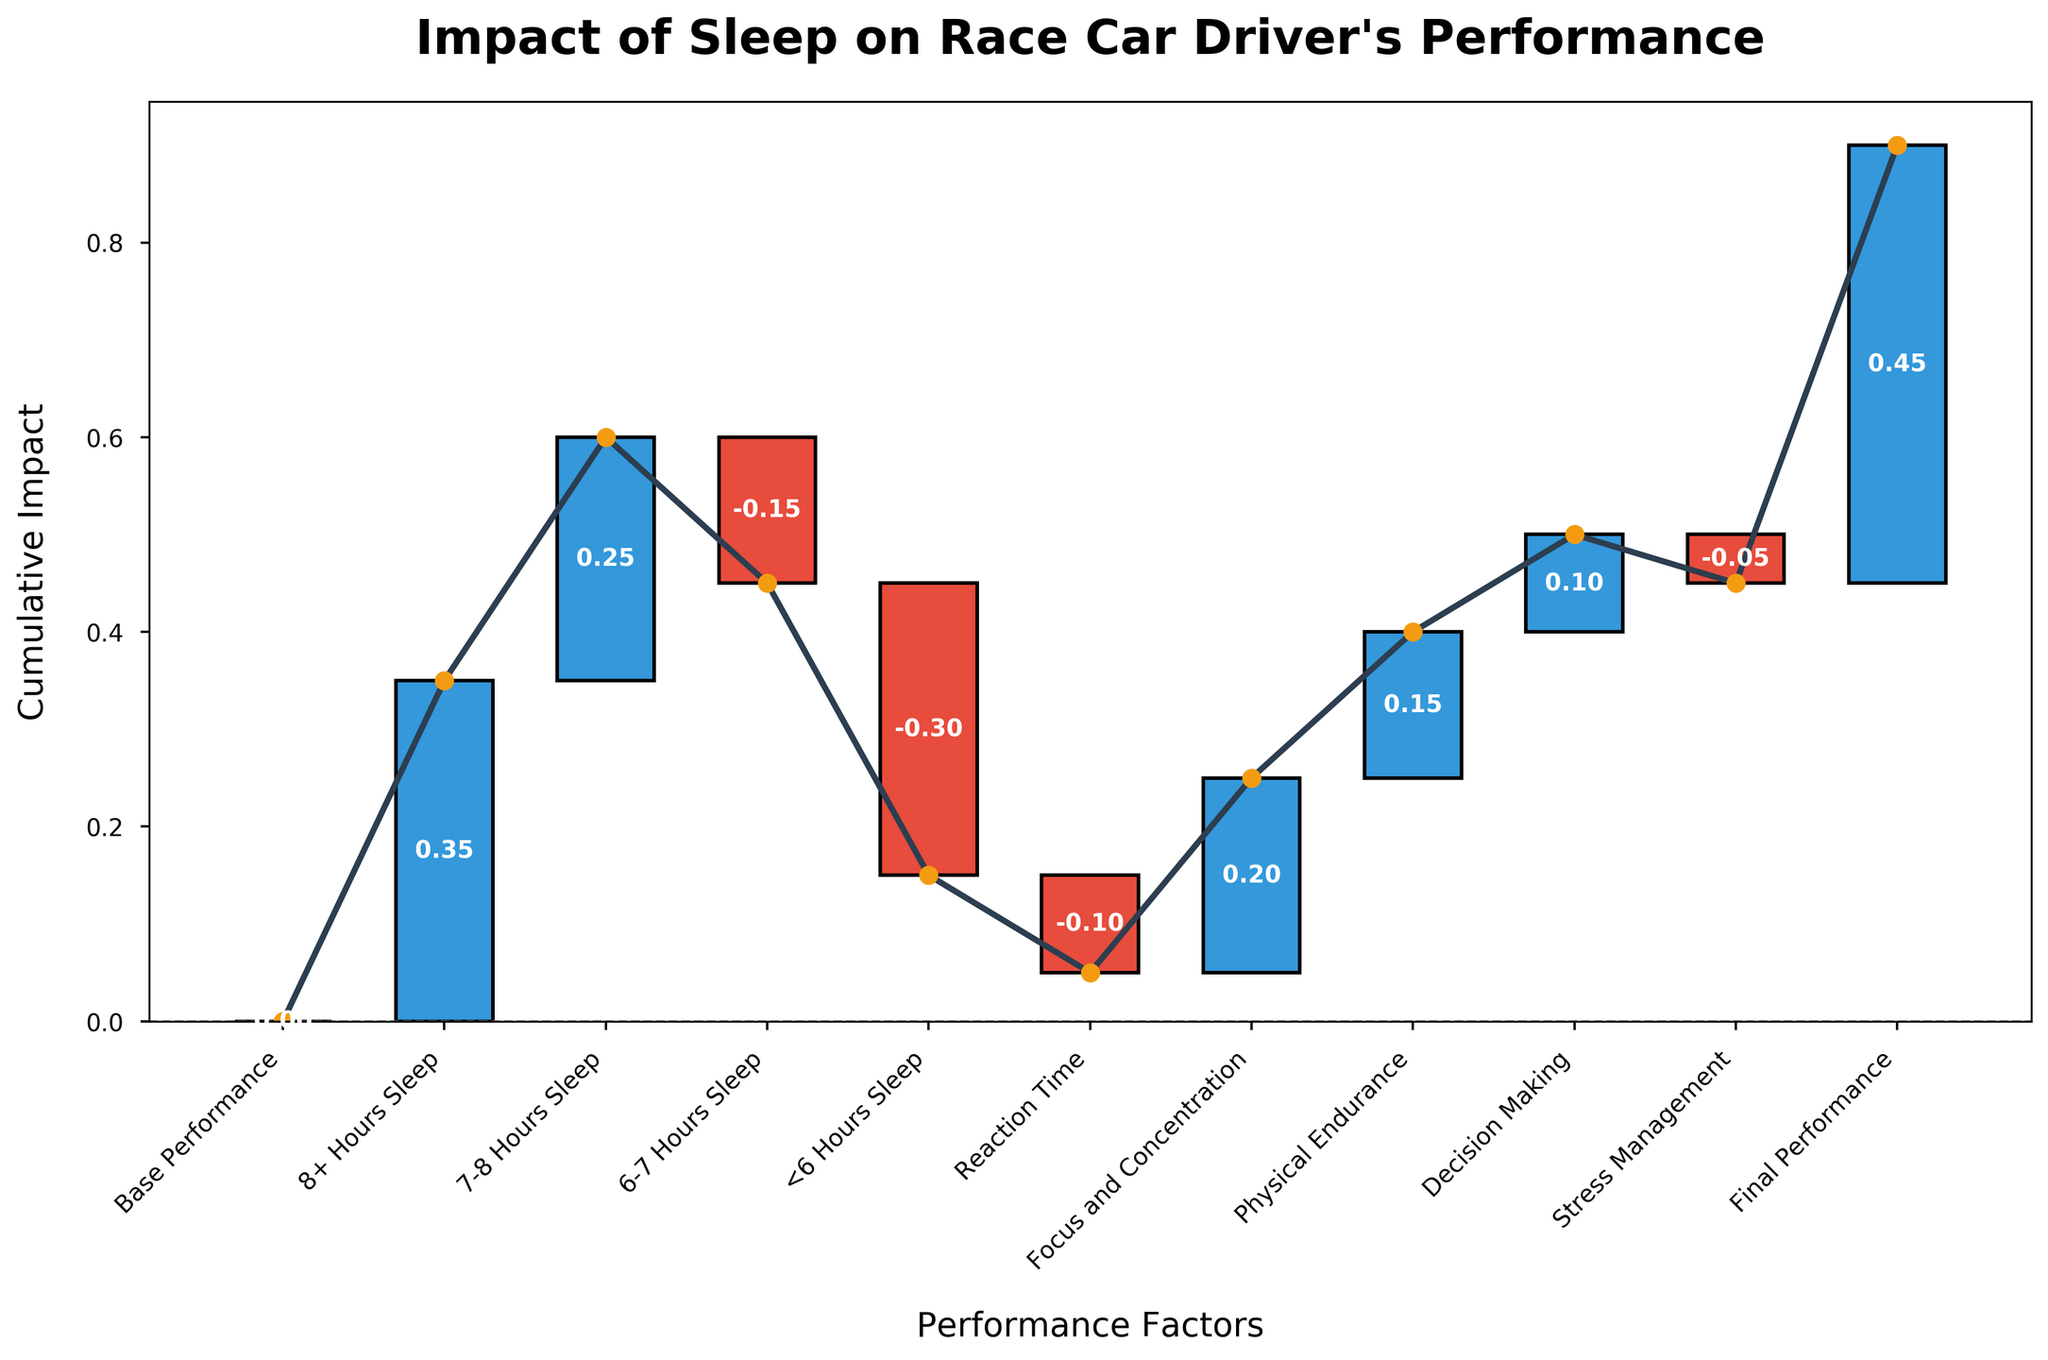What is the title of the plot? The title of the plot is clearly displayed at the top.
Answer: Impact of Sleep on Race Car Driver's Performance How does sleep duration of less than 6 hours affect the performance metric? The bar labeled "<6 Hours Sleep" shows a negative value, indicating it decreases the performance.
Answer: -0.30 What is the cumulative impact on performance after considering 7-8 hours of sleep? Summing the base performance (0) and the impact of 7-8 hours of sleep (+0.25) gives the cumulative impact.
Answer: +0.25 Which sleep duration category has a positive impact but less than 8+ hours of sleep? By comparing the labels and their values—both 7-8 Hours Sleep (+0.25) and 6-7 Hours Sleep (-0.15), only the 7-8 Hours Sleep has a positive impact, but less than 8+ Hours Sleep (+0.35).
Answer: 7-8 Hours Sleep Which factor contributes the most negatively to performance? Among the bars with negative values, "<6 Hours Sleep" has the lowest value (-0.30).
Answer: <6 Hours Sleep How much does the total impact of physical endurance, decision making, and stress management influence the final performance? Adding up the values for physical endurance (+0.15), decision making (+0.10), and stress management (-0.05) gives the total impact.
Answer: +0.20 What is the difference in impact between 8+ Hours Sleep and Reaction Time on performance? Subtract the value of reaction time (-0.10) from the value of 8+ Hours Sleep (+0.35).
Answer: +0.45 What is the final performance impact after accounting for all factors? The figure shows the final cumulative impact listed as Final Performance.
Answer: +0.45 Which factor appears to improve performance the most? By observing the height of the positive bars, 8+ Hours Sleep has the highest positive impact (+0.35).
Answer: 8+ Hours Sleep What category has a negative influence after Focus and Concentration? Looking at the sequence, the next negative impact after Focus and Concentration (+0.20) is Stress Management (-0.05).
Answer: Stress Management 